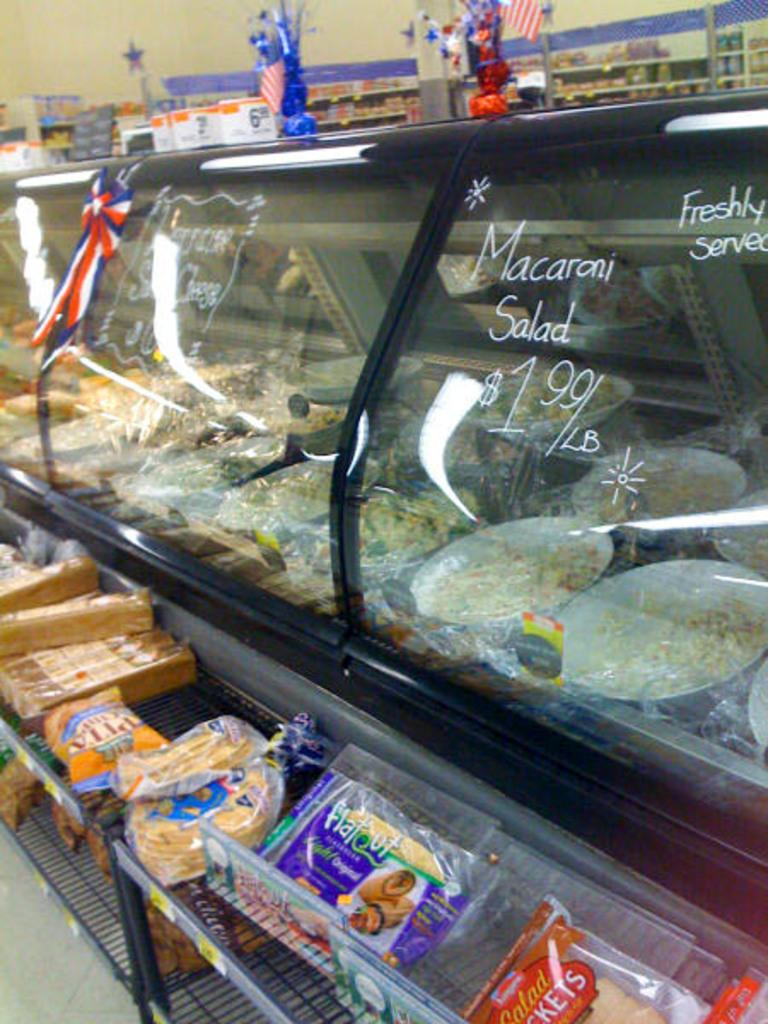<image>
Render a clear and concise summary of the photo. A glass case at a grocery store with macaroni salad for sale. 